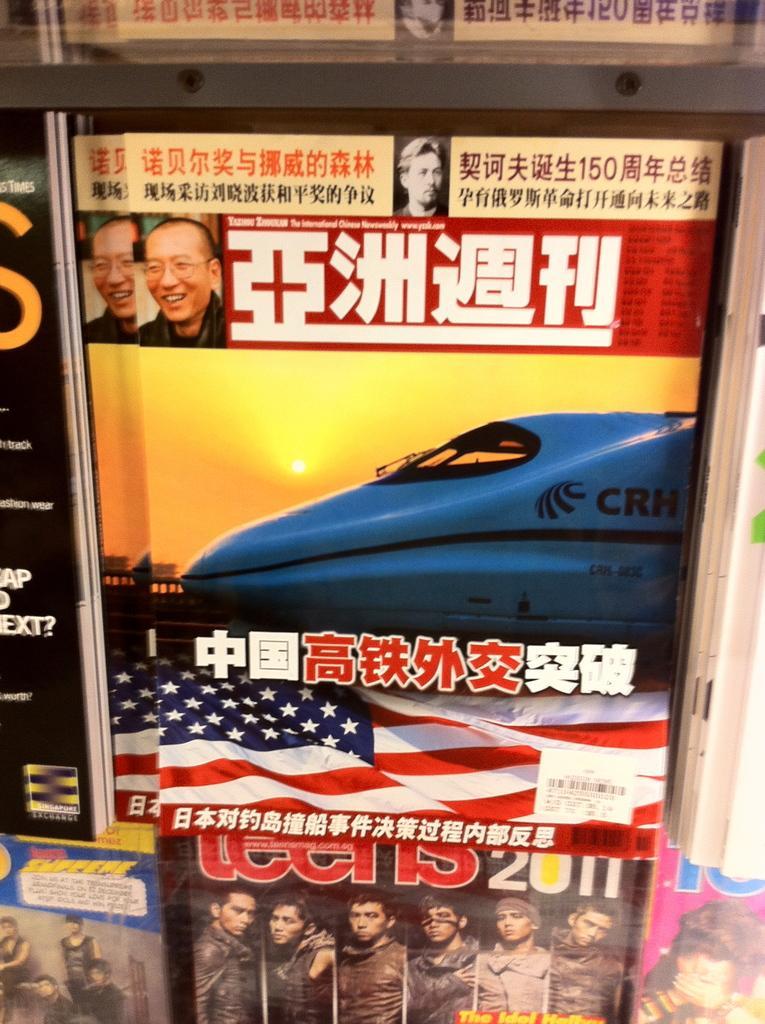Describe this image in one or two sentences. In the picture we can see some posts which are in different languages. 